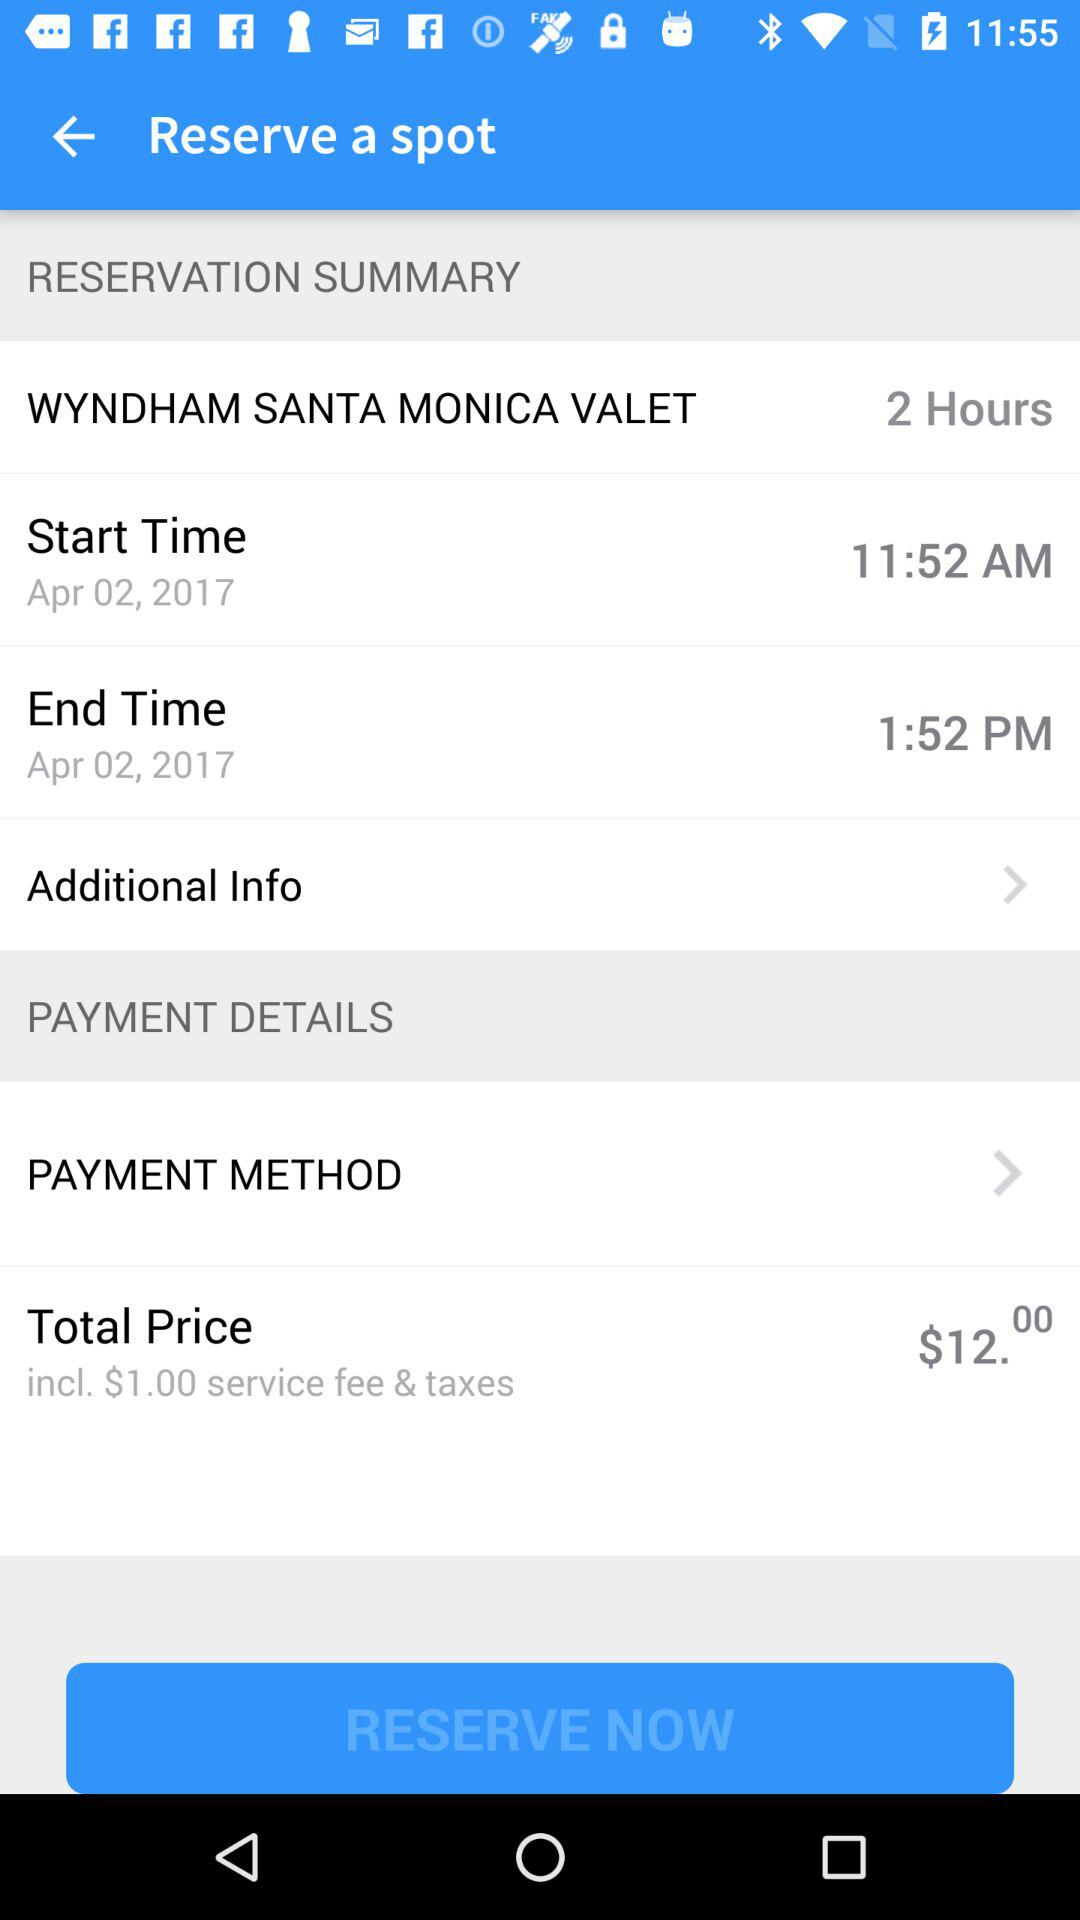For how much time duration has the spot been reserved? The spot has been reserved for 2 hours. 